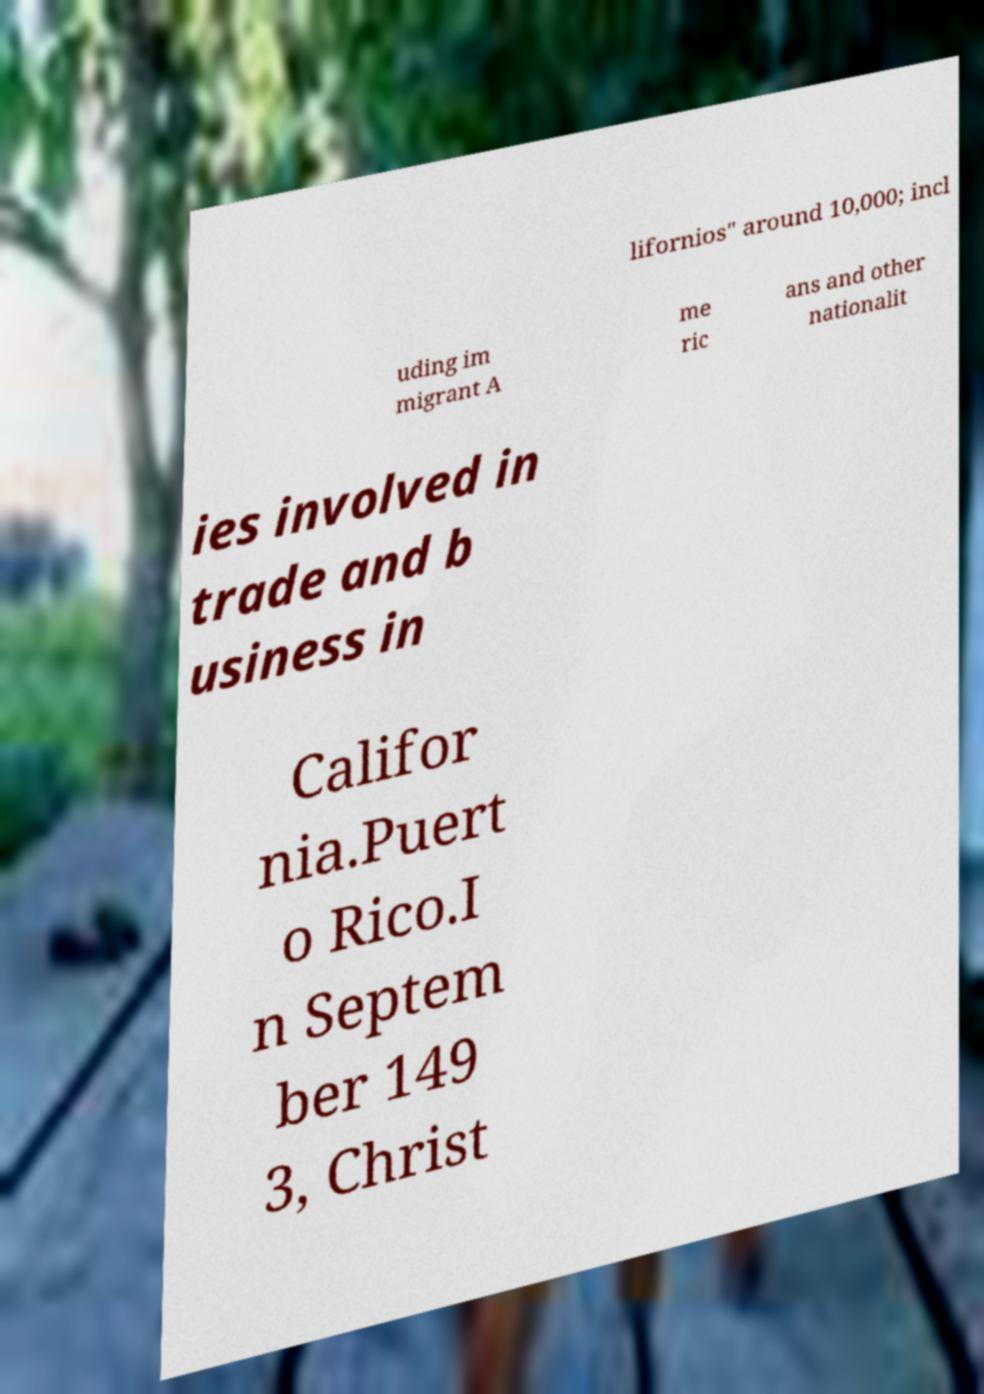What messages or text are displayed in this image? I need them in a readable, typed format. lifornios" around 10,000; incl uding im migrant A me ric ans and other nationalit ies involved in trade and b usiness in Califor nia.Puert o Rico.I n Septem ber 149 3, Christ 